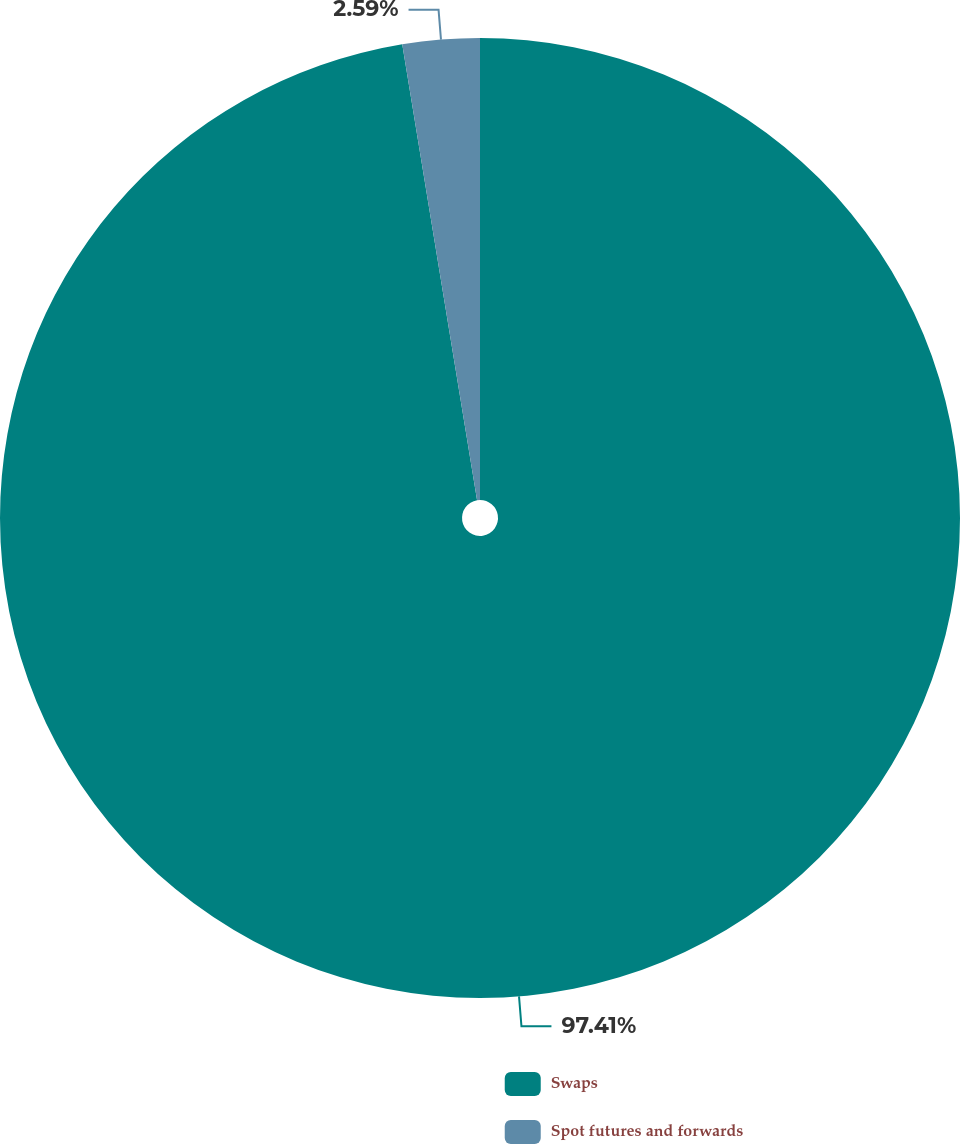<chart> <loc_0><loc_0><loc_500><loc_500><pie_chart><fcel>Swaps<fcel>Spot futures and forwards<nl><fcel>97.41%<fcel>2.59%<nl></chart> 